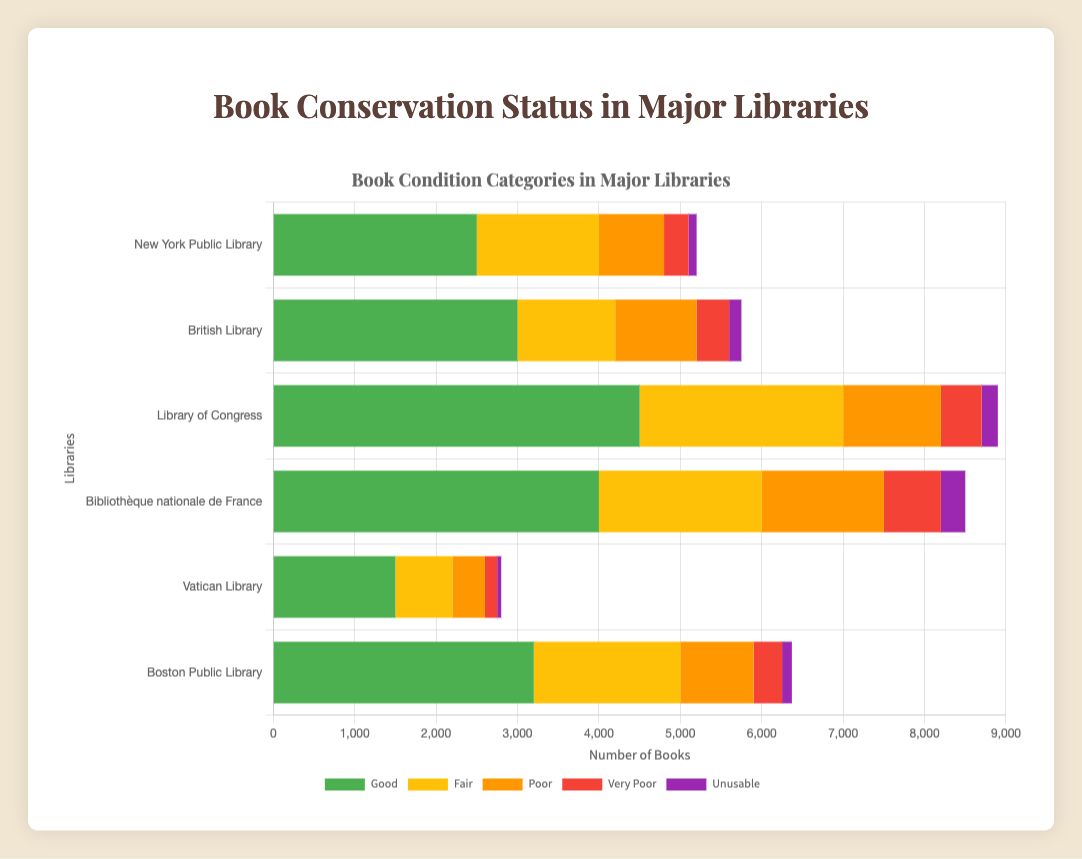Which library has the largest number of books in 'Good' condition? By observing the lengths of the bars representing 'Good' condition in each library, the Library of Congress has the longest bar, indicating it has the highest count.
Answer: Library of Congress How many more books are in 'Fair' condition at the Bibliothèque nationale de France compared to the Vatican Library? The Bibliothèque nationale de France has 2000 books in 'Fair' condition, and the Vatican Library has 700. The difference is 2000 - 700.
Answer: 1300 What is the total number of books in 'Poor' condition across all libraries combined? Sum the values of books in 'Poor' condition from each library: 800 (New York Public Library) + 1000 (British Library) + 1200 (Library of Congress) + 1500 (Bibliothèque nationale de France) + 400 (Vatican Library) + 900 (Boston Public Library). The total is 5800.
Answer: 5800 Which library has the highest number of 'Unusable' books? By comparing the lengths of the bars for 'Unusable' books in each library, Bibliothèque nationale de France has the longest bar in this category.
Answer: Bibliothèque nationale de France What is the combined count of books in 'Very Poor' condition for the British Library and the Boston Public Library? The British Library has 400 books in 'Very Poor' condition, and the Boston Public Library has 350. Therefore, the combined total is 400 + 350.
Answer: 750 How does the number of 'Fair' condition books at the Library of Congress compare to those in 'Good' condition at the Vatican Library? The Library of Congress has 2500 'Fair' condition books and the Vatican Library has 1500 'Good' condition books. 2500 is greater than 1500.
Answer: 2500 > 1500 Which library has the smallest percentage of books in 'Good' condition relative to its total collection? Calculate the total number of books in each library and the percentage of 'Good' condition books. The Vatican Library has the fewest books in 'Good' condition relative to its total collection (1500 out of 2800).
Answer: Vatican Library 